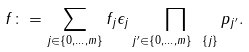Convert formula to latex. <formula><loc_0><loc_0><loc_500><loc_500>f \colon = \sum _ { j \in \{ 0 , \dots , m \} } f _ { j } \epsilon _ { j } \prod _ { j ^ { \prime } \in \{ 0 , \dots , m \} \ \{ j \} } p _ { j ^ { \prime } } .</formula> 